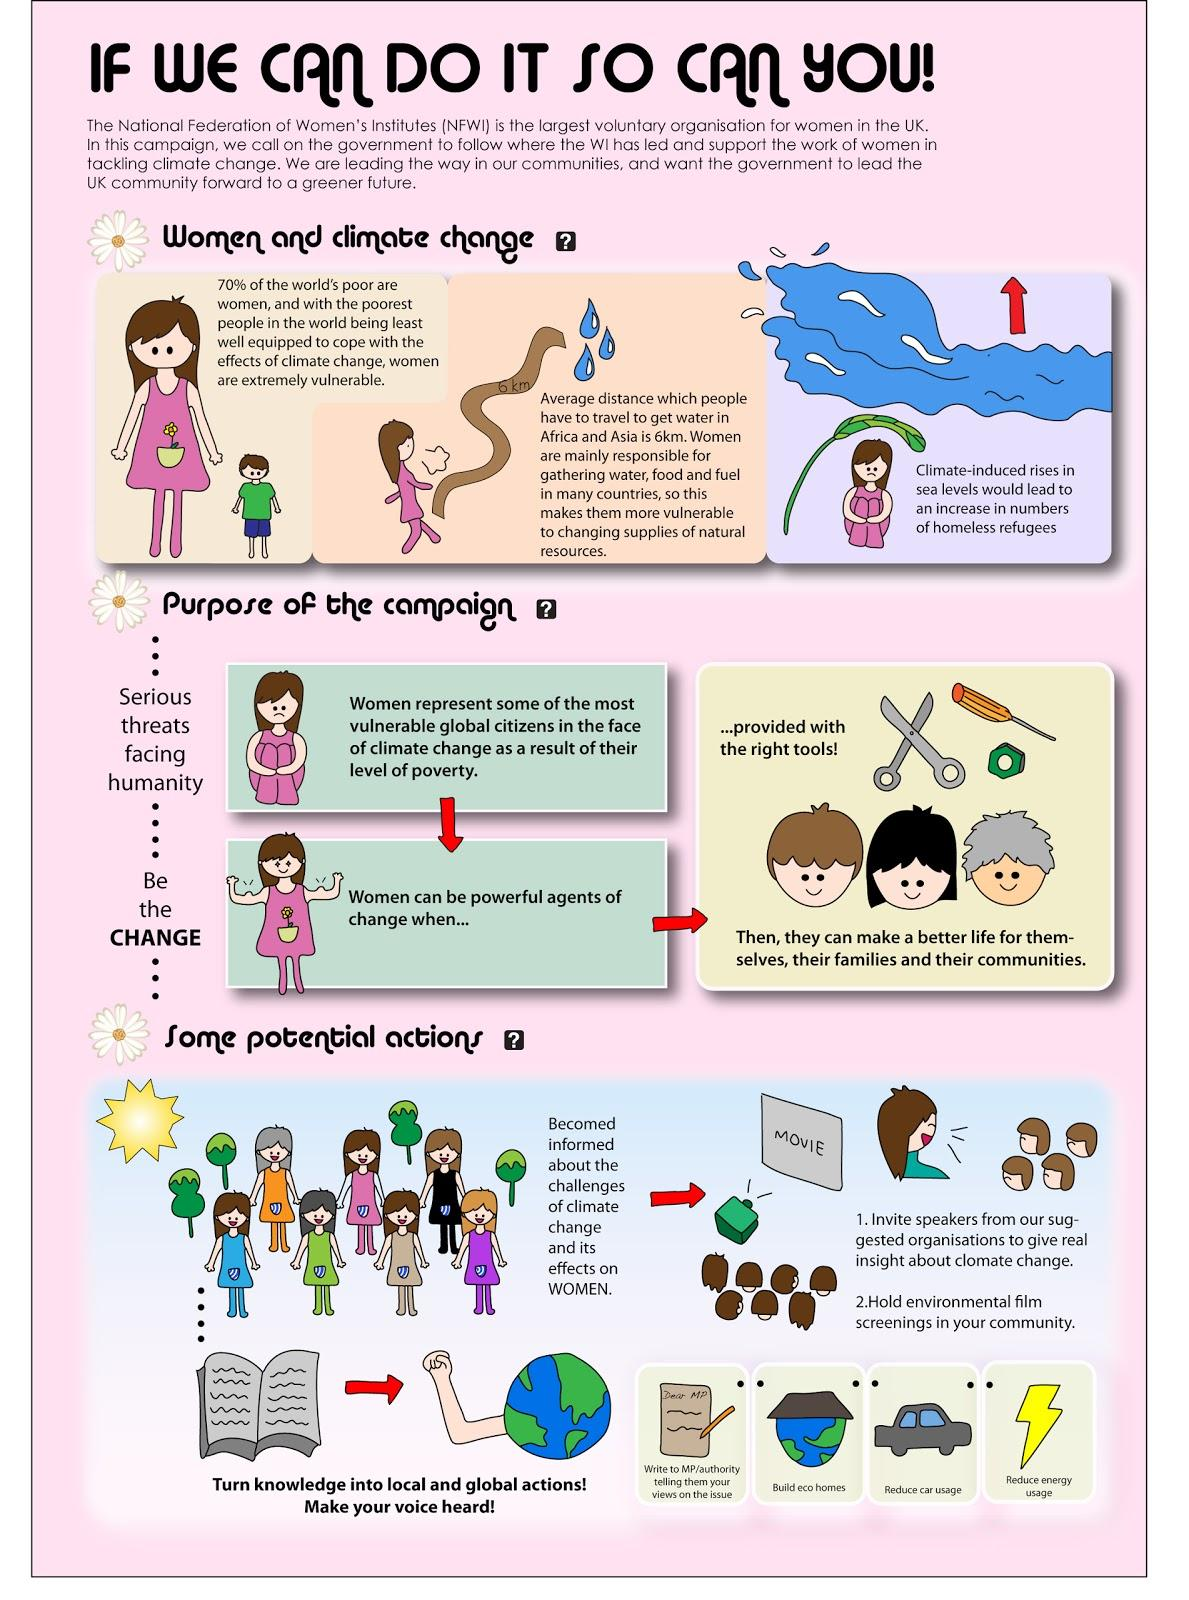Specify some key components in this picture. According to statistics, only 30% of the world's poor are not women. 